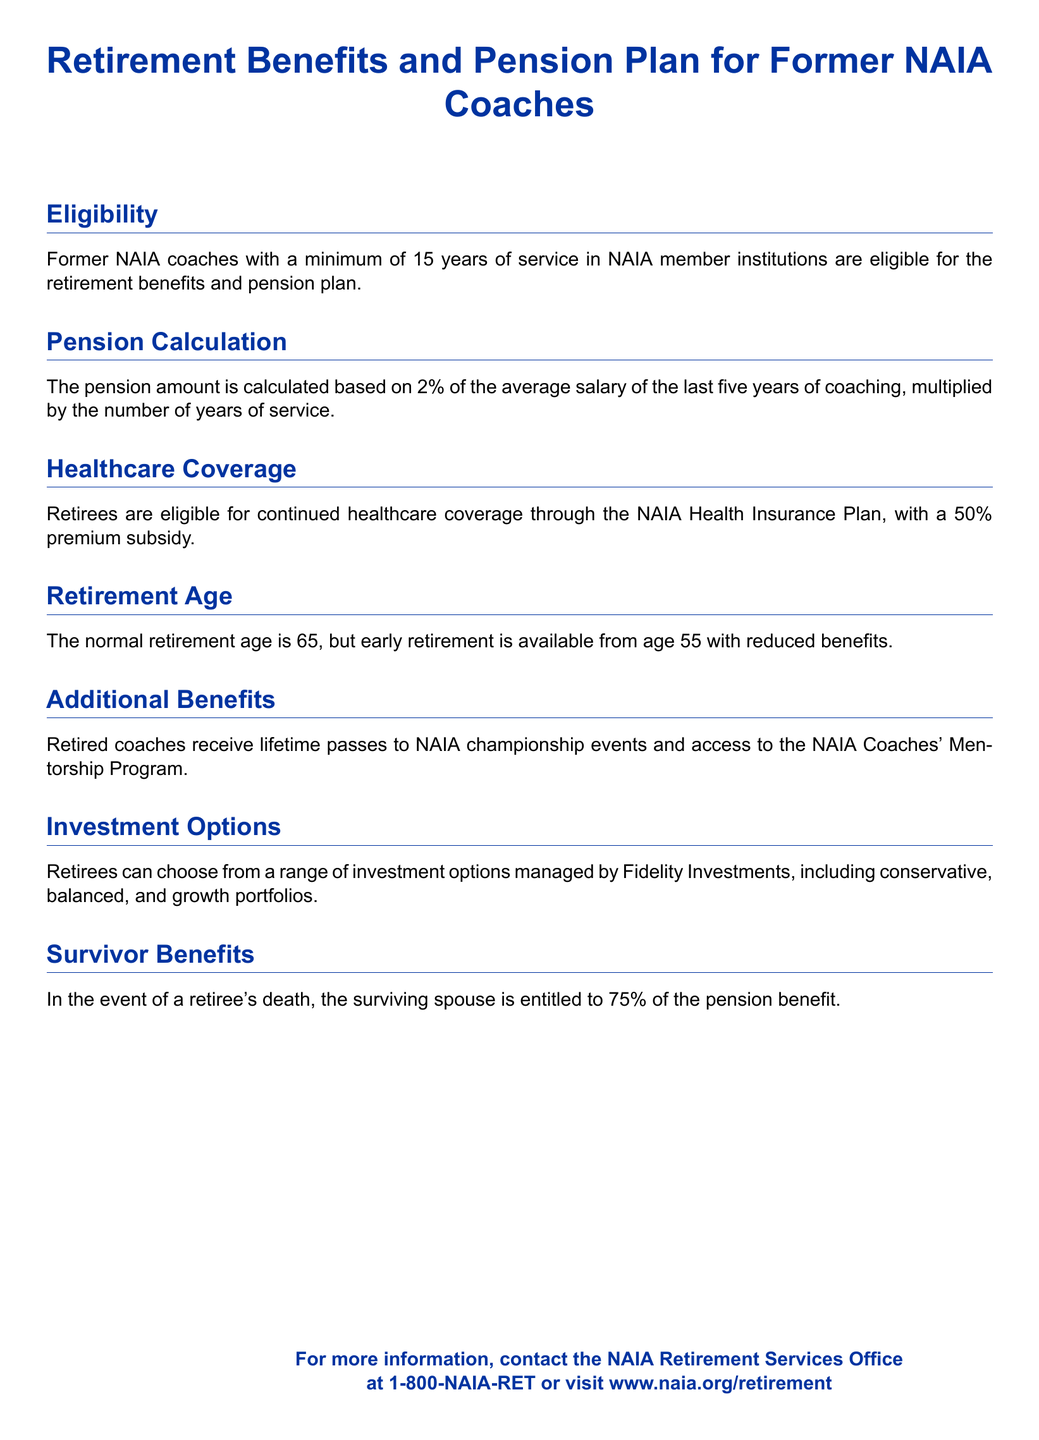What is the minimum years of service required for eligibility? The document states that a minimum of 15 years of service is required for eligibility for retirement benefits and pension plan.
Answer: 15 years What percentage of the average salary is used for pension calculation? According to the document, the pension amount is calculated based on 2% of the average salary.
Answer: 2% At what age can a retiree choose early retirement? The document mentions that early retirement is available from age 55.
Answer: 55 What is the healthcare premium subsidy for retirees? The document states that retirees are eligible for a 50% premium subsidy for healthcare coverage.
Answer: 50% What additional benefits do retired coaches receive? The document specifies that retired coaches receive lifetime passes to NAIA championship events and access to the NAIA Coaches' Mentorship Program.
Answer: Lifetime passes and mentorship access How much pension benefit does a surviving spouse receive? The document explains that the surviving spouse is entitled to 75% of the pension benefit.
Answer: 75% What investment company manages the retirement options? The document states that the investment options are managed by Fidelity Investments.
Answer: Fidelity Investments What is the normal retirement age mentioned in the document? The document indicates that the normal retirement age is 65.
Answer: 65 